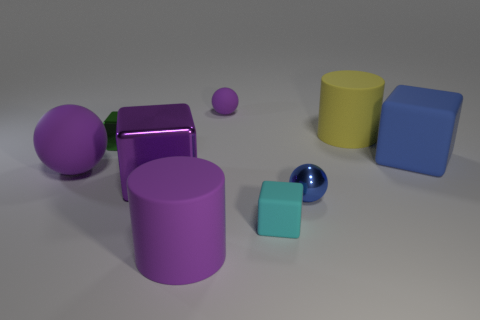How many objects are there and can you sort them by size? In the image, there are seven objects. Starting from the largest to the smallest, they are: the large yellow cylinder, the large purple cube, the large blue cube, the large purple shiny sphere, the mid-sized purple cylinder, the small aqua cube, and finally, the small dark blue shiny sphere. 